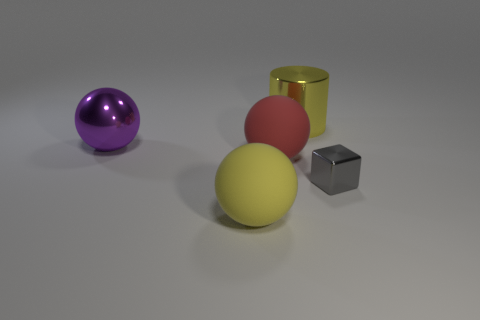What is the material of the gray block? The gray block appears to be made of metal, characterized by its distinct, shiny metallic luster and reflective surface which is typical of metals. 